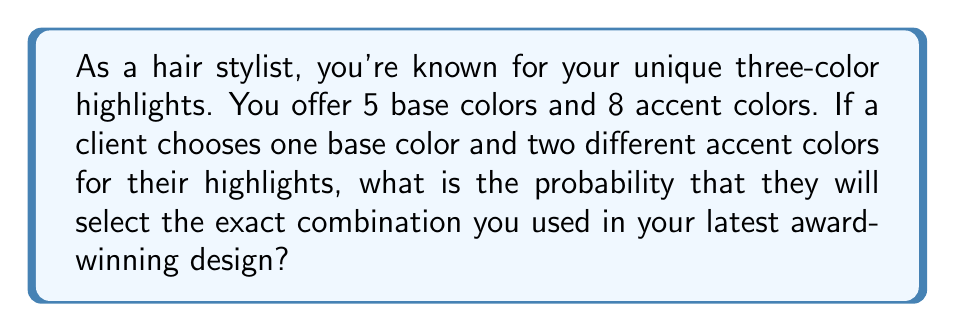Show me your answer to this math problem. Let's approach this step-by-step:

1) First, we need to calculate the total number of possible combinations:
   - There are 5 choices for the base color
   - For the first accent color, there are 8 choices
   - For the second accent color, there are 7 choices (as it must be different from the first)

2) The total number of possible combinations is:
   $$ 5 \times 8 \times 7 = 280 $$

3) Now, we need to consider the probability of selecting the exact combination used in your award-winning design. There is only one way to do this - by selecting the exact three colors you used.

4) In probability theory, when an event can only happen in one way out of a total number of equally likely outcomes, the probability is:

   $$ P(\text{event}) = \frac{\text{number of favorable outcomes}}{\text{total number of possible outcomes}} $$

5) In this case:
   $$ P(\text{selecting award-winning combination}) = \frac{1}{280} $$

6) This can be simplified to:
   $$ P(\text{selecting award-winning combination}) = \frac{1}{280} = 0.00357142857... $$

7) Expressed as a percentage, this is approximately 0.3571%
Answer: $\frac{1}{280}$ or approximately $0.003571$ (0.3571%) 